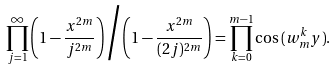Convert formula to latex. <formula><loc_0><loc_0><loc_500><loc_500>\prod _ { j = 1 } ^ { \infty } \left ( 1 - \frac { x ^ { 2 m } } { j ^ { 2 m } } \right ) \Big / \left ( 1 - \frac { x ^ { 2 m } } { ( 2 j ) ^ { 2 m } } \right ) = \prod _ { k = 0 } ^ { m - 1 } \cos { ( w _ { m } ^ { k } y ) } .</formula> 